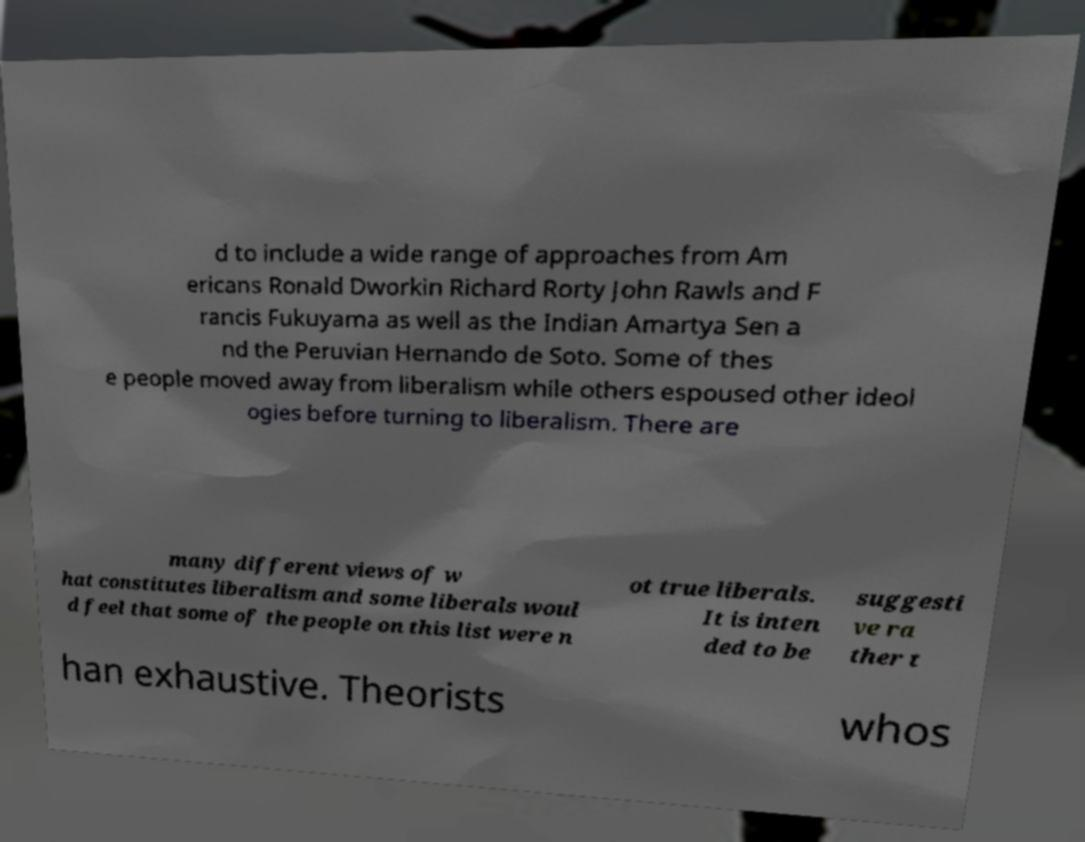Could you assist in decoding the text presented in this image and type it out clearly? d to include a wide range of approaches from Am ericans Ronald Dworkin Richard Rorty John Rawls and F rancis Fukuyama as well as the Indian Amartya Sen a nd the Peruvian Hernando de Soto. Some of thes e people moved away from liberalism while others espoused other ideol ogies before turning to liberalism. There are many different views of w hat constitutes liberalism and some liberals woul d feel that some of the people on this list were n ot true liberals. It is inten ded to be suggesti ve ra ther t han exhaustive. Theorists whos 